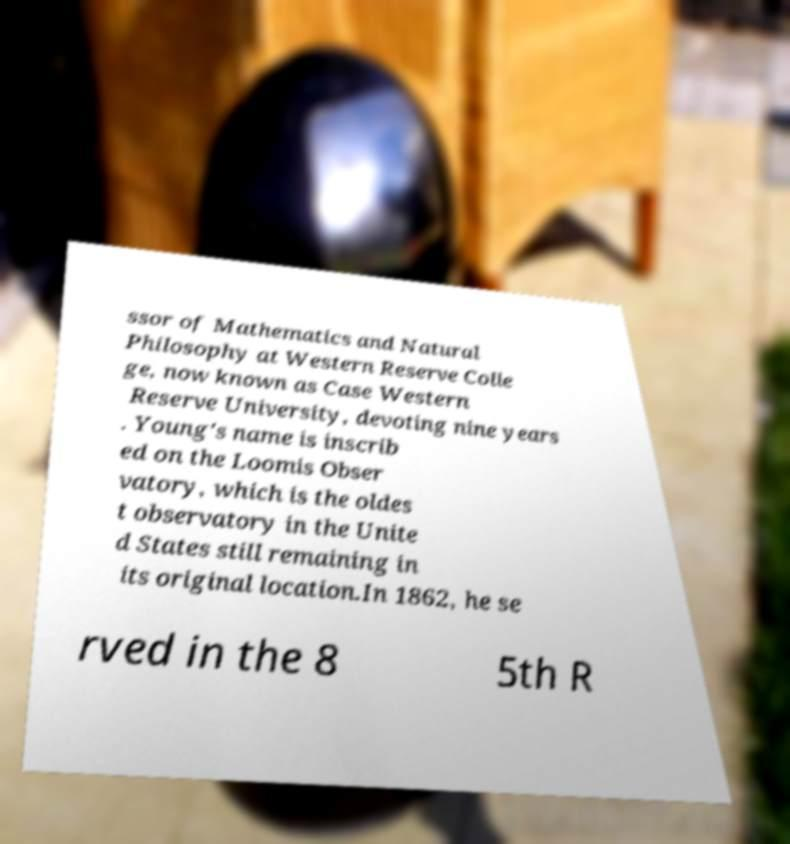Can you accurately transcribe the text from the provided image for me? ssor of Mathematics and Natural Philosophy at Western Reserve Colle ge, now known as Case Western Reserve University, devoting nine years . Young's name is inscrib ed on the Loomis Obser vatory, which is the oldes t observatory in the Unite d States still remaining in its original location.In 1862, he se rved in the 8 5th R 